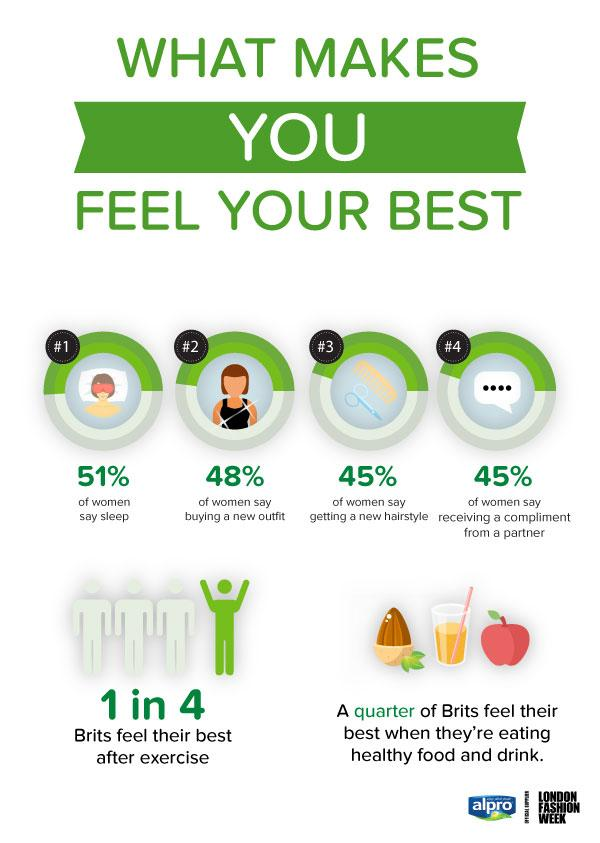Point out several critical features in this image. The term 'Brits' is used to refer to people from Britain. The third and fourth factors that contribute to women feeling their best are getting a new hairstyle and receiving a compliment from a partner. According to a recent survey, 51% of women believe that sleep makes them feel their best. According to a recent survey, a significant percentage of Britons believe that exercise is the best way to feel their best. Specifically, 25% of those surveyed reported that exercise is their preferred method of improving their overall well-being. A quarter of Brits report feeling their best when they consume healthy food and drink. 